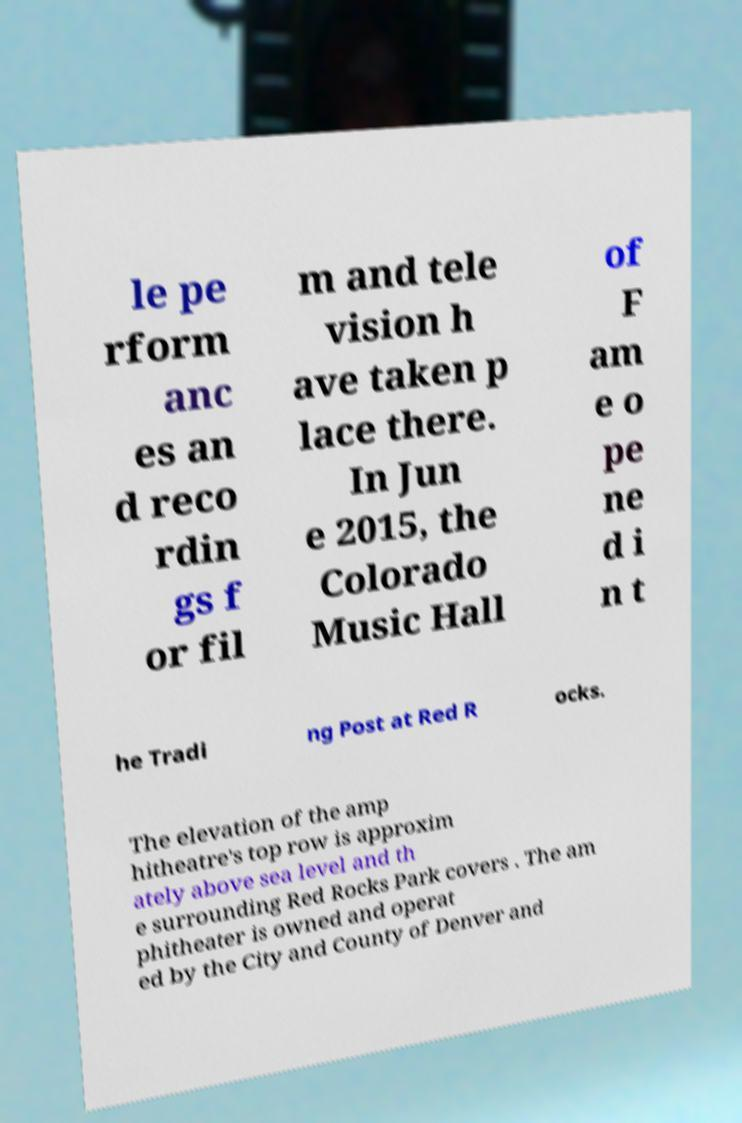Please read and relay the text visible in this image. What does it say? le pe rform anc es an d reco rdin gs f or fil m and tele vision h ave taken p lace there. In Jun e 2015, the Colorado Music Hall of F am e o pe ne d i n t he Tradi ng Post at Red R ocks. The elevation of the amp hitheatre's top row is approxim ately above sea level and th e surrounding Red Rocks Park covers . The am phitheater is owned and operat ed by the City and County of Denver and 